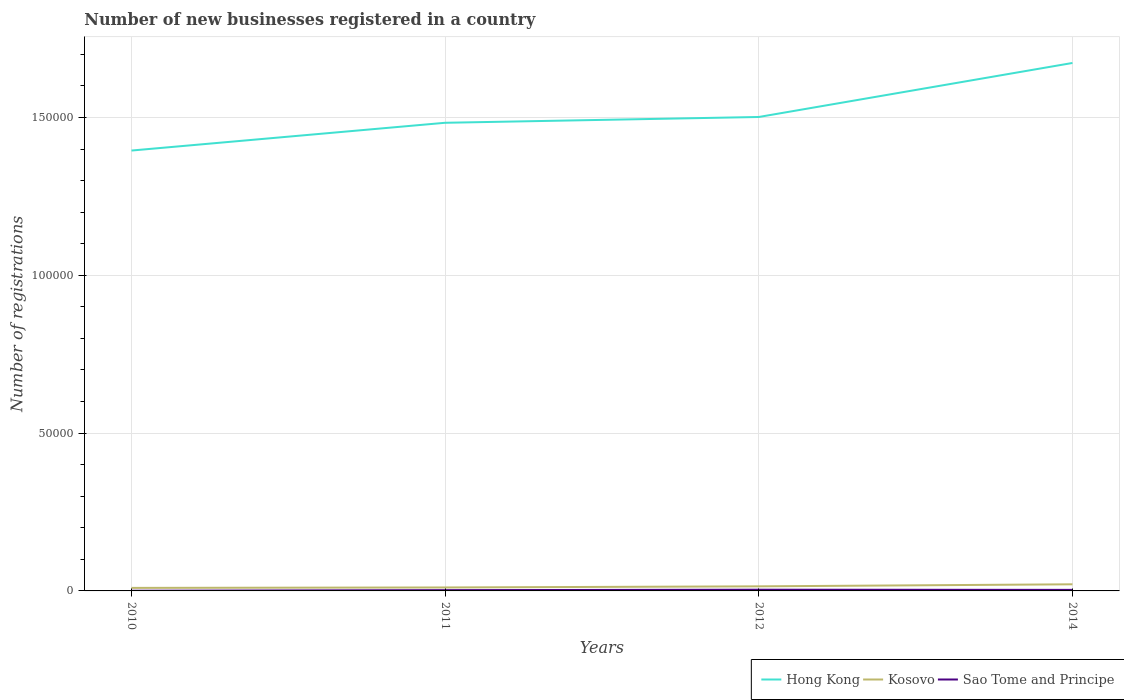How many different coloured lines are there?
Offer a terse response. 3. Does the line corresponding to Sao Tome and Principe intersect with the line corresponding to Hong Kong?
Your answer should be compact. No. Is the number of lines equal to the number of legend labels?
Keep it short and to the point. Yes. Across all years, what is the maximum number of new businesses registered in Kosovo?
Offer a terse response. 962. What is the total number of new businesses registered in Kosovo in the graph?
Provide a succinct answer. -487. What is the difference between the highest and the second highest number of new businesses registered in Sao Tome and Principe?
Make the answer very short. 331. Is the number of new businesses registered in Hong Kong strictly greater than the number of new businesses registered in Sao Tome and Principe over the years?
Ensure brevity in your answer.  No. How many lines are there?
Ensure brevity in your answer.  3. What is the difference between two consecutive major ticks on the Y-axis?
Your response must be concise. 5.00e+04. Does the graph contain any zero values?
Keep it short and to the point. No. What is the title of the graph?
Your answer should be very brief. Number of new businesses registered in a country. Does "Croatia" appear as one of the legend labels in the graph?
Your response must be concise. No. What is the label or title of the Y-axis?
Your answer should be compact. Number of registrations. What is the Number of registrations in Hong Kong in 2010?
Your answer should be very brief. 1.40e+05. What is the Number of registrations in Kosovo in 2010?
Offer a very short reply. 962. What is the Number of registrations of Hong Kong in 2011?
Your answer should be compact. 1.48e+05. What is the Number of registrations of Kosovo in 2011?
Your answer should be very brief. 1095. What is the Number of registrations in Sao Tome and Principe in 2011?
Provide a short and direct response. 241. What is the Number of registrations in Hong Kong in 2012?
Your response must be concise. 1.50e+05. What is the Number of registrations of Kosovo in 2012?
Ensure brevity in your answer.  1449. What is the Number of registrations in Sao Tome and Principe in 2012?
Provide a short and direct response. 388. What is the Number of registrations of Hong Kong in 2014?
Your answer should be compact. 1.67e+05. What is the Number of registrations in Kosovo in 2014?
Make the answer very short. 2100. What is the Number of registrations of Sao Tome and Principe in 2014?
Make the answer very short. 332. Across all years, what is the maximum Number of registrations of Hong Kong?
Provide a short and direct response. 1.67e+05. Across all years, what is the maximum Number of registrations of Kosovo?
Give a very brief answer. 2100. Across all years, what is the maximum Number of registrations of Sao Tome and Principe?
Make the answer very short. 388. Across all years, what is the minimum Number of registrations of Hong Kong?
Offer a terse response. 1.40e+05. Across all years, what is the minimum Number of registrations in Kosovo?
Your answer should be compact. 962. What is the total Number of registrations in Hong Kong in the graph?
Offer a terse response. 6.05e+05. What is the total Number of registrations of Kosovo in the graph?
Keep it short and to the point. 5606. What is the total Number of registrations in Sao Tome and Principe in the graph?
Your answer should be compact. 1018. What is the difference between the Number of registrations in Hong Kong in 2010 and that in 2011?
Ensure brevity in your answer.  -8799. What is the difference between the Number of registrations in Kosovo in 2010 and that in 2011?
Give a very brief answer. -133. What is the difference between the Number of registrations in Sao Tome and Principe in 2010 and that in 2011?
Make the answer very short. -184. What is the difference between the Number of registrations in Hong Kong in 2010 and that in 2012?
Keep it short and to the point. -1.06e+04. What is the difference between the Number of registrations of Kosovo in 2010 and that in 2012?
Your answer should be compact. -487. What is the difference between the Number of registrations in Sao Tome and Principe in 2010 and that in 2012?
Ensure brevity in your answer.  -331. What is the difference between the Number of registrations in Hong Kong in 2010 and that in 2014?
Your answer should be compact. -2.78e+04. What is the difference between the Number of registrations in Kosovo in 2010 and that in 2014?
Your response must be concise. -1138. What is the difference between the Number of registrations in Sao Tome and Principe in 2010 and that in 2014?
Offer a very short reply. -275. What is the difference between the Number of registrations of Hong Kong in 2011 and that in 2012?
Keep it short and to the point. -1836. What is the difference between the Number of registrations in Kosovo in 2011 and that in 2012?
Ensure brevity in your answer.  -354. What is the difference between the Number of registrations in Sao Tome and Principe in 2011 and that in 2012?
Give a very brief answer. -147. What is the difference between the Number of registrations of Hong Kong in 2011 and that in 2014?
Ensure brevity in your answer.  -1.90e+04. What is the difference between the Number of registrations in Kosovo in 2011 and that in 2014?
Your answer should be very brief. -1005. What is the difference between the Number of registrations in Sao Tome and Principe in 2011 and that in 2014?
Offer a terse response. -91. What is the difference between the Number of registrations in Hong Kong in 2012 and that in 2014?
Give a very brief answer. -1.71e+04. What is the difference between the Number of registrations in Kosovo in 2012 and that in 2014?
Your answer should be compact. -651. What is the difference between the Number of registrations of Sao Tome and Principe in 2012 and that in 2014?
Your response must be concise. 56. What is the difference between the Number of registrations of Hong Kong in 2010 and the Number of registrations of Kosovo in 2011?
Offer a terse response. 1.38e+05. What is the difference between the Number of registrations of Hong Kong in 2010 and the Number of registrations of Sao Tome and Principe in 2011?
Provide a short and direct response. 1.39e+05. What is the difference between the Number of registrations in Kosovo in 2010 and the Number of registrations in Sao Tome and Principe in 2011?
Ensure brevity in your answer.  721. What is the difference between the Number of registrations in Hong Kong in 2010 and the Number of registrations in Kosovo in 2012?
Your answer should be very brief. 1.38e+05. What is the difference between the Number of registrations of Hong Kong in 2010 and the Number of registrations of Sao Tome and Principe in 2012?
Offer a terse response. 1.39e+05. What is the difference between the Number of registrations of Kosovo in 2010 and the Number of registrations of Sao Tome and Principe in 2012?
Your answer should be compact. 574. What is the difference between the Number of registrations of Hong Kong in 2010 and the Number of registrations of Kosovo in 2014?
Keep it short and to the point. 1.37e+05. What is the difference between the Number of registrations of Hong Kong in 2010 and the Number of registrations of Sao Tome and Principe in 2014?
Make the answer very short. 1.39e+05. What is the difference between the Number of registrations in Kosovo in 2010 and the Number of registrations in Sao Tome and Principe in 2014?
Your answer should be very brief. 630. What is the difference between the Number of registrations in Hong Kong in 2011 and the Number of registrations in Kosovo in 2012?
Keep it short and to the point. 1.47e+05. What is the difference between the Number of registrations in Hong Kong in 2011 and the Number of registrations in Sao Tome and Principe in 2012?
Offer a terse response. 1.48e+05. What is the difference between the Number of registrations in Kosovo in 2011 and the Number of registrations in Sao Tome and Principe in 2012?
Give a very brief answer. 707. What is the difference between the Number of registrations in Hong Kong in 2011 and the Number of registrations in Kosovo in 2014?
Offer a very short reply. 1.46e+05. What is the difference between the Number of registrations in Hong Kong in 2011 and the Number of registrations in Sao Tome and Principe in 2014?
Make the answer very short. 1.48e+05. What is the difference between the Number of registrations of Kosovo in 2011 and the Number of registrations of Sao Tome and Principe in 2014?
Keep it short and to the point. 763. What is the difference between the Number of registrations of Hong Kong in 2012 and the Number of registrations of Kosovo in 2014?
Offer a very short reply. 1.48e+05. What is the difference between the Number of registrations of Hong Kong in 2012 and the Number of registrations of Sao Tome and Principe in 2014?
Provide a succinct answer. 1.50e+05. What is the difference between the Number of registrations of Kosovo in 2012 and the Number of registrations of Sao Tome and Principe in 2014?
Offer a very short reply. 1117. What is the average Number of registrations of Hong Kong per year?
Provide a short and direct response. 1.51e+05. What is the average Number of registrations of Kosovo per year?
Offer a terse response. 1401.5. What is the average Number of registrations of Sao Tome and Principe per year?
Provide a succinct answer. 254.5. In the year 2010, what is the difference between the Number of registrations of Hong Kong and Number of registrations of Kosovo?
Keep it short and to the point. 1.39e+05. In the year 2010, what is the difference between the Number of registrations in Hong Kong and Number of registrations in Sao Tome and Principe?
Your answer should be very brief. 1.39e+05. In the year 2010, what is the difference between the Number of registrations of Kosovo and Number of registrations of Sao Tome and Principe?
Keep it short and to the point. 905. In the year 2011, what is the difference between the Number of registrations in Hong Kong and Number of registrations in Kosovo?
Ensure brevity in your answer.  1.47e+05. In the year 2011, what is the difference between the Number of registrations in Hong Kong and Number of registrations in Sao Tome and Principe?
Keep it short and to the point. 1.48e+05. In the year 2011, what is the difference between the Number of registrations of Kosovo and Number of registrations of Sao Tome and Principe?
Your answer should be very brief. 854. In the year 2012, what is the difference between the Number of registrations in Hong Kong and Number of registrations in Kosovo?
Offer a very short reply. 1.49e+05. In the year 2012, what is the difference between the Number of registrations of Hong Kong and Number of registrations of Sao Tome and Principe?
Make the answer very short. 1.50e+05. In the year 2012, what is the difference between the Number of registrations in Kosovo and Number of registrations in Sao Tome and Principe?
Ensure brevity in your answer.  1061. In the year 2014, what is the difference between the Number of registrations in Hong Kong and Number of registrations in Kosovo?
Your answer should be very brief. 1.65e+05. In the year 2014, what is the difference between the Number of registrations of Hong Kong and Number of registrations of Sao Tome and Principe?
Provide a succinct answer. 1.67e+05. In the year 2014, what is the difference between the Number of registrations in Kosovo and Number of registrations in Sao Tome and Principe?
Give a very brief answer. 1768. What is the ratio of the Number of registrations of Hong Kong in 2010 to that in 2011?
Your response must be concise. 0.94. What is the ratio of the Number of registrations of Kosovo in 2010 to that in 2011?
Your answer should be very brief. 0.88. What is the ratio of the Number of registrations of Sao Tome and Principe in 2010 to that in 2011?
Make the answer very short. 0.24. What is the ratio of the Number of registrations in Hong Kong in 2010 to that in 2012?
Provide a short and direct response. 0.93. What is the ratio of the Number of registrations of Kosovo in 2010 to that in 2012?
Ensure brevity in your answer.  0.66. What is the ratio of the Number of registrations of Sao Tome and Principe in 2010 to that in 2012?
Provide a succinct answer. 0.15. What is the ratio of the Number of registrations in Hong Kong in 2010 to that in 2014?
Ensure brevity in your answer.  0.83. What is the ratio of the Number of registrations in Kosovo in 2010 to that in 2014?
Provide a succinct answer. 0.46. What is the ratio of the Number of registrations in Sao Tome and Principe in 2010 to that in 2014?
Your response must be concise. 0.17. What is the ratio of the Number of registrations in Hong Kong in 2011 to that in 2012?
Your answer should be very brief. 0.99. What is the ratio of the Number of registrations of Kosovo in 2011 to that in 2012?
Provide a succinct answer. 0.76. What is the ratio of the Number of registrations in Sao Tome and Principe in 2011 to that in 2012?
Offer a very short reply. 0.62. What is the ratio of the Number of registrations of Hong Kong in 2011 to that in 2014?
Ensure brevity in your answer.  0.89. What is the ratio of the Number of registrations in Kosovo in 2011 to that in 2014?
Your answer should be compact. 0.52. What is the ratio of the Number of registrations in Sao Tome and Principe in 2011 to that in 2014?
Offer a very short reply. 0.73. What is the ratio of the Number of registrations in Hong Kong in 2012 to that in 2014?
Offer a terse response. 0.9. What is the ratio of the Number of registrations in Kosovo in 2012 to that in 2014?
Your response must be concise. 0.69. What is the ratio of the Number of registrations of Sao Tome and Principe in 2012 to that in 2014?
Keep it short and to the point. 1.17. What is the difference between the highest and the second highest Number of registrations of Hong Kong?
Your answer should be very brief. 1.71e+04. What is the difference between the highest and the second highest Number of registrations in Kosovo?
Your answer should be very brief. 651. What is the difference between the highest and the lowest Number of registrations in Hong Kong?
Ensure brevity in your answer.  2.78e+04. What is the difference between the highest and the lowest Number of registrations in Kosovo?
Offer a very short reply. 1138. What is the difference between the highest and the lowest Number of registrations in Sao Tome and Principe?
Offer a very short reply. 331. 